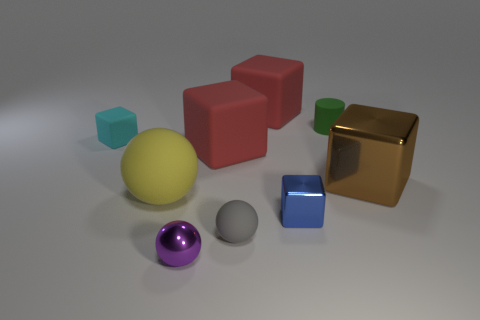Subtract all brown blocks. How many blocks are left? 4 Subtract all big metallic cubes. How many cubes are left? 4 Add 1 large brown objects. How many objects exist? 10 Subtract all gray cylinders. Subtract all yellow balls. How many cylinders are left? 1 Subtract all balls. How many objects are left? 6 Subtract 0 gray cylinders. How many objects are left? 9 Subtract all cylinders. Subtract all purple metal objects. How many objects are left? 7 Add 8 small blue cubes. How many small blue cubes are left? 9 Add 1 small blue blocks. How many small blue blocks exist? 2 